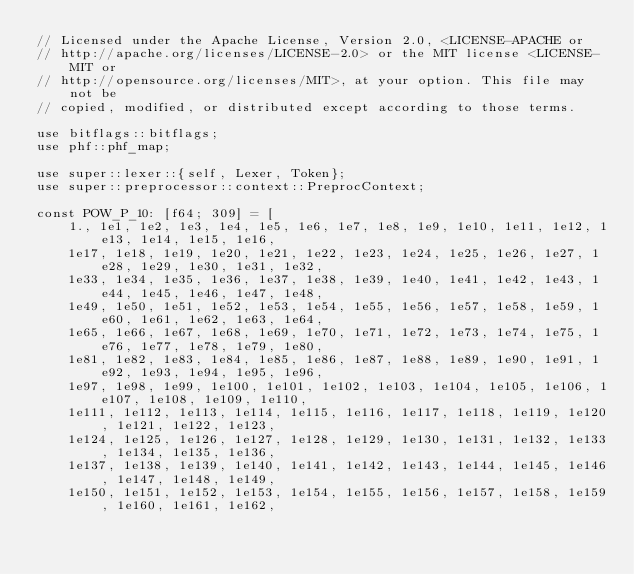<code> <loc_0><loc_0><loc_500><loc_500><_Rust_>// Licensed under the Apache License, Version 2.0, <LICENSE-APACHE or
// http://apache.org/licenses/LICENSE-2.0> or the MIT license <LICENSE-MIT or
// http://opensource.org/licenses/MIT>, at your option. This file may not be
// copied, modified, or distributed except according to those terms.

use bitflags::bitflags;
use phf::phf_map;

use super::lexer::{self, Lexer, Token};
use super::preprocessor::context::PreprocContext;

const POW_P_10: [f64; 309] = [
    1., 1e1, 1e2, 1e3, 1e4, 1e5, 1e6, 1e7, 1e8, 1e9, 1e10, 1e11, 1e12, 1e13, 1e14, 1e15, 1e16,
    1e17, 1e18, 1e19, 1e20, 1e21, 1e22, 1e23, 1e24, 1e25, 1e26, 1e27, 1e28, 1e29, 1e30, 1e31, 1e32,
    1e33, 1e34, 1e35, 1e36, 1e37, 1e38, 1e39, 1e40, 1e41, 1e42, 1e43, 1e44, 1e45, 1e46, 1e47, 1e48,
    1e49, 1e50, 1e51, 1e52, 1e53, 1e54, 1e55, 1e56, 1e57, 1e58, 1e59, 1e60, 1e61, 1e62, 1e63, 1e64,
    1e65, 1e66, 1e67, 1e68, 1e69, 1e70, 1e71, 1e72, 1e73, 1e74, 1e75, 1e76, 1e77, 1e78, 1e79, 1e80,
    1e81, 1e82, 1e83, 1e84, 1e85, 1e86, 1e87, 1e88, 1e89, 1e90, 1e91, 1e92, 1e93, 1e94, 1e95, 1e96,
    1e97, 1e98, 1e99, 1e100, 1e101, 1e102, 1e103, 1e104, 1e105, 1e106, 1e107, 1e108, 1e109, 1e110,
    1e111, 1e112, 1e113, 1e114, 1e115, 1e116, 1e117, 1e118, 1e119, 1e120, 1e121, 1e122, 1e123,
    1e124, 1e125, 1e126, 1e127, 1e128, 1e129, 1e130, 1e131, 1e132, 1e133, 1e134, 1e135, 1e136,
    1e137, 1e138, 1e139, 1e140, 1e141, 1e142, 1e143, 1e144, 1e145, 1e146, 1e147, 1e148, 1e149,
    1e150, 1e151, 1e152, 1e153, 1e154, 1e155, 1e156, 1e157, 1e158, 1e159, 1e160, 1e161, 1e162,</code> 